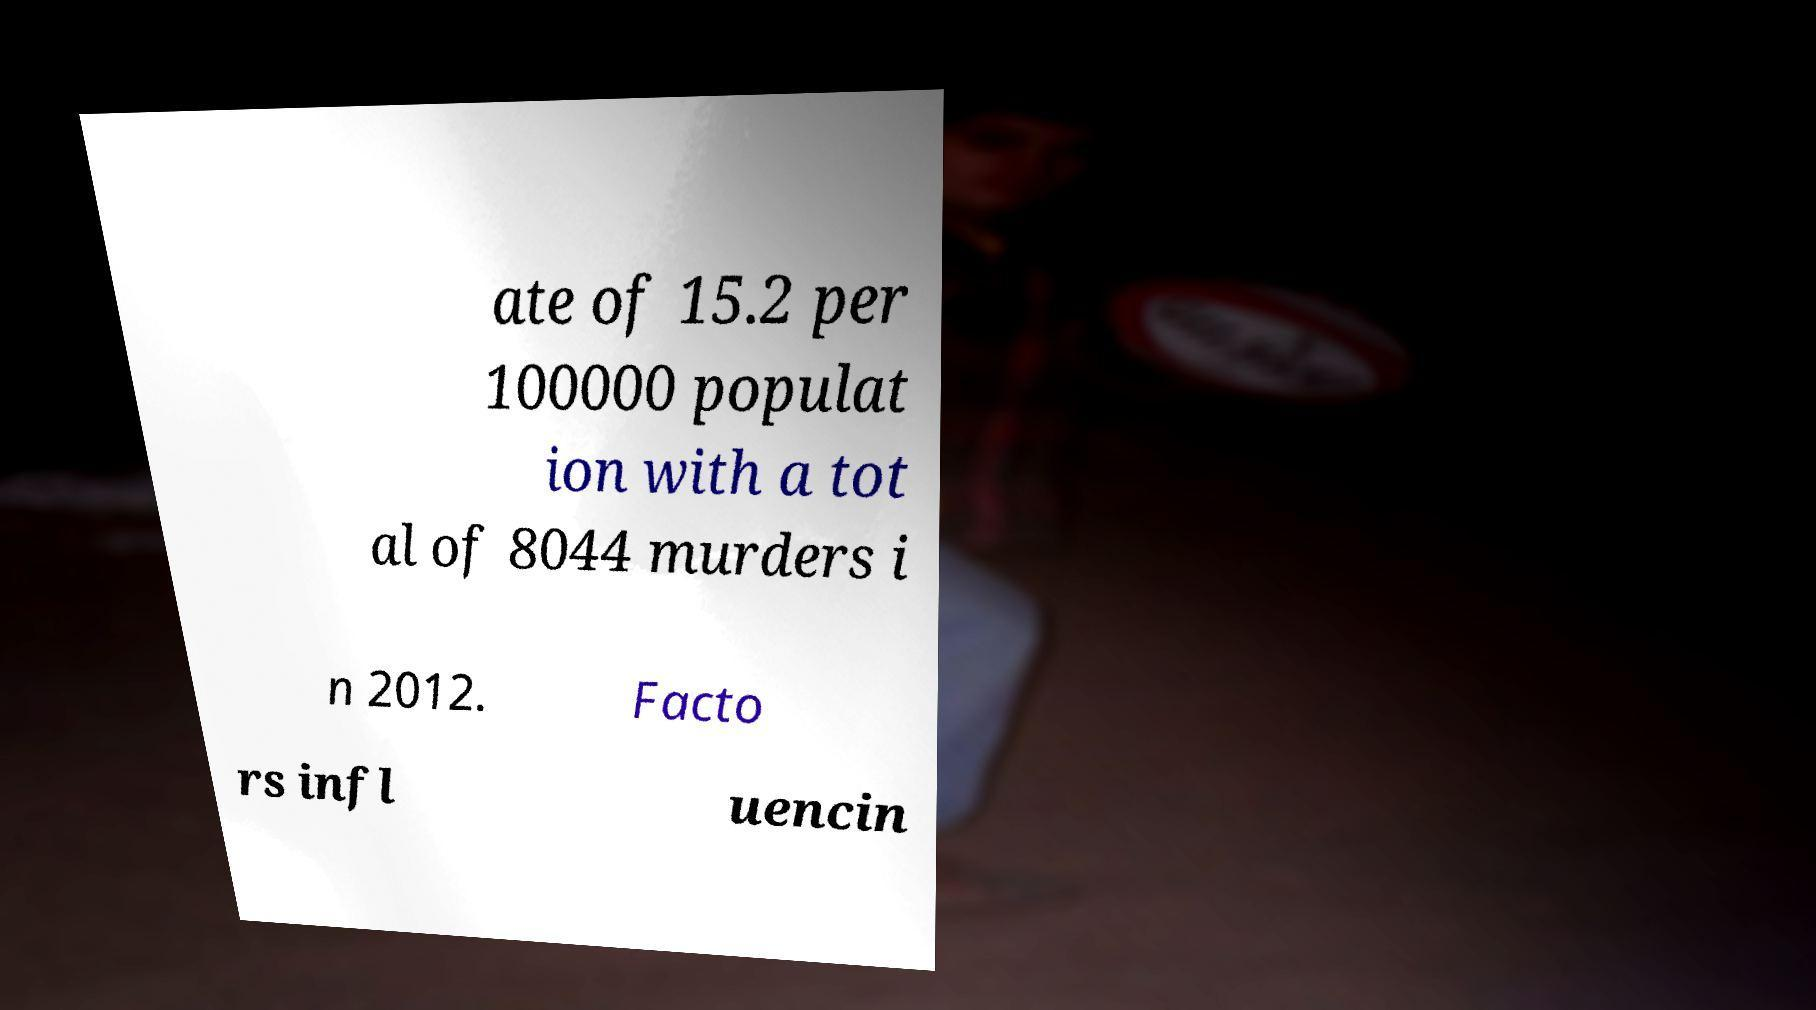What messages or text are displayed in this image? I need them in a readable, typed format. ate of 15.2 per 100000 populat ion with a tot al of 8044 murders i n 2012. Facto rs infl uencin 